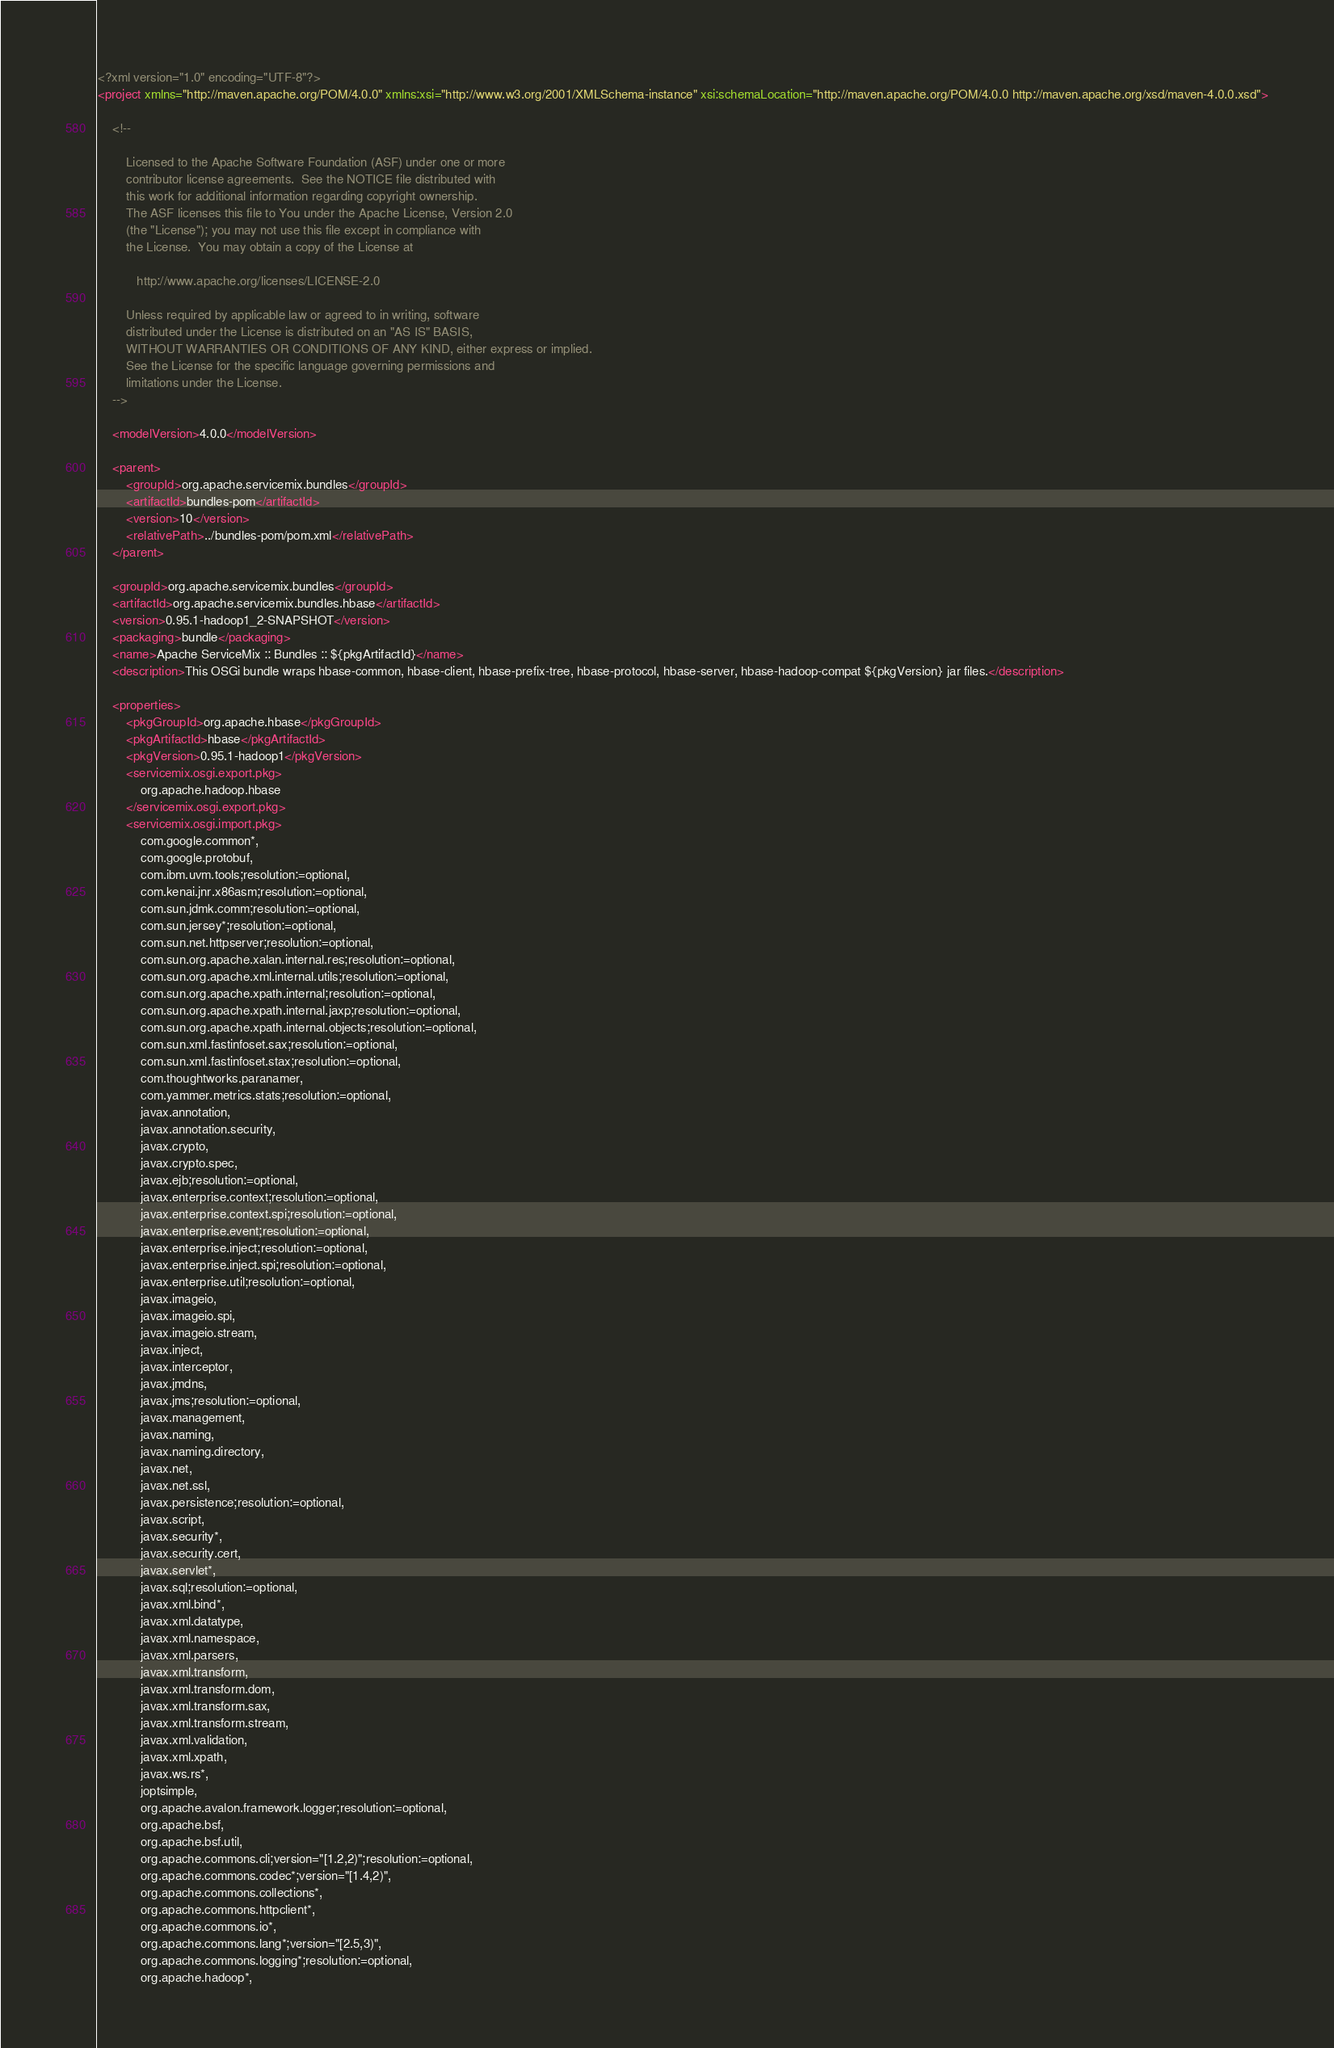<code> <loc_0><loc_0><loc_500><loc_500><_XML_><?xml version="1.0" encoding="UTF-8"?>
<project xmlns="http://maven.apache.org/POM/4.0.0" xmlns:xsi="http://www.w3.org/2001/XMLSchema-instance" xsi:schemaLocation="http://maven.apache.org/POM/4.0.0 http://maven.apache.org/xsd/maven-4.0.0.xsd">

    <!--

        Licensed to the Apache Software Foundation (ASF) under one or more
        contributor license agreements.  See the NOTICE file distributed with
        this work for additional information regarding copyright ownership.
        The ASF licenses this file to You under the Apache License, Version 2.0
        (the "License"); you may not use this file except in compliance with
        the License.  You may obtain a copy of the License at

           http://www.apache.org/licenses/LICENSE-2.0

        Unless required by applicable law or agreed to in writing, software
        distributed under the License is distributed on an "AS IS" BASIS,
        WITHOUT WARRANTIES OR CONDITIONS OF ANY KIND, either express or implied.
        See the License for the specific language governing permissions and
        limitations under the License.
    -->

    <modelVersion>4.0.0</modelVersion>

    <parent>
        <groupId>org.apache.servicemix.bundles</groupId>
        <artifactId>bundles-pom</artifactId>
        <version>10</version>
        <relativePath>../bundles-pom/pom.xml</relativePath>
    </parent>

    <groupId>org.apache.servicemix.bundles</groupId>
    <artifactId>org.apache.servicemix.bundles.hbase</artifactId>
    <version>0.95.1-hadoop1_2-SNAPSHOT</version>
    <packaging>bundle</packaging>
    <name>Apache ServiceMix :: Bundles :: ${pkgArtifactId}</name>
    <description>This OSGi bundle wraps hbase-common, hbase-client, hbase-prefix-tree, hbase-protocol, hbase-server, hbase-hadoop-compat ${pkgVersion} jar files.</description>

    <properties>
        <pkgGroupId>org.apache.hbase</pkgGroupId>
        <pkgArtifactId>hbase</pkgArtifactId>
        <pkgVersion>0.95.1-hadoop1</pkgVersion>
        <servicemix.osgi.export.pkg>
            org.apache.hadoop.hbase
        </servicemix.osgi.export.pkg>
        <servicemix.osgi.import.pkg>
            com.google.common*,
            com.google.protobuf,
            com.ibm.uvm.tools;resolution:=optional,
            com.kenai.jnr.x86asm;resolution:=optional,
            com.sun.jdmk.comm;resolution:=optional,
            com.sun.jersey*;resolution:=optional,
            com.sun.net.httpserver;resolution:=optional,
            com.sun.org.apache.xalan.internal.res;resolution:=optional,
            com.sun.org.apache.xml.internal.utils;resolution:=optional,
            com.sun.org.apache.xpath.internal;resolution:=optional,
            com.sun.org.apache.xpath.internal.jaxp;resolution:=optional,
            com.sun.org.apache.xpath.internal.objects;resolution:=optional,
            com.sun.xml.fastinfoset.sax;resolution:=optional,
            com.sun.xml.fastinfoset.stax;resolution:=optional,
            com.thoughtworks.paranamer,
            com.yammer.metrics.stats;resolution:=optional,
            javax.annotation,
            javax.annotation.security,
            javax.crypto,
            javax.crypto.spec,
            javax.ejb;resolution:=optional,
            javax.enterprise.context;resolution:=optional,
            javax.enterprise.context.spi;resolution:=optional,
            javax.enterprise.event;resolution:=optional,
            javax.enterprise.inject;resolution:=optional,
            javax.enterprise.inject.spi;resolution:=optional,
            javax.enterprise.util;resolution:=optional,
            javax.imageio,
            javax.imageio.spi,
            javax.imageio.stream,
            javax.inject,
            javax.interceptor,
            javax.jmdns,
            javax.jms;resolution:=optional,
            javax.management,
            javax.naming,
            javax.naming.directory,
            javax.net,
            javax.net.ssl,
            javax.persistence;resolution:=optional,
            javax.script,
            javax.security*,
            javax.security.cert,
            javax.servlet*,
            javax.sql;resolution:=optional,
            javax.xml.bind*,
            javax.xml.datatype,
            javax.xml.namespace,
            javax.xml.parsers,
            javax.xml.transform,
            javax.xml.transform.dom,
            javax.xml.transform.sax,
            javax.xml.transform.stream,
            javax.xml.validation,
            javax.xml.xpath,
            javax.ws.rs*,
            joptsimple,
            org.apache.avalon.framework.logger;resolution:=optional,
            org.apache.bsf,
            org.apache.bsf.util,
            org.apache.commons.cli;version="[1.2,2)";resolution:=optional,
            org.apache.commons.codec*;version="[1.4,2)",
            org.apache.commons.collections*,
            org.apache.commons.httpclient*,
            org.apache.commons.io*,
            org.apache.commons.lang*;version="[2.5,3)",
            org.apache.commons.logging*;resolution:=optional,
            org.apache.hadoop*,</code> 